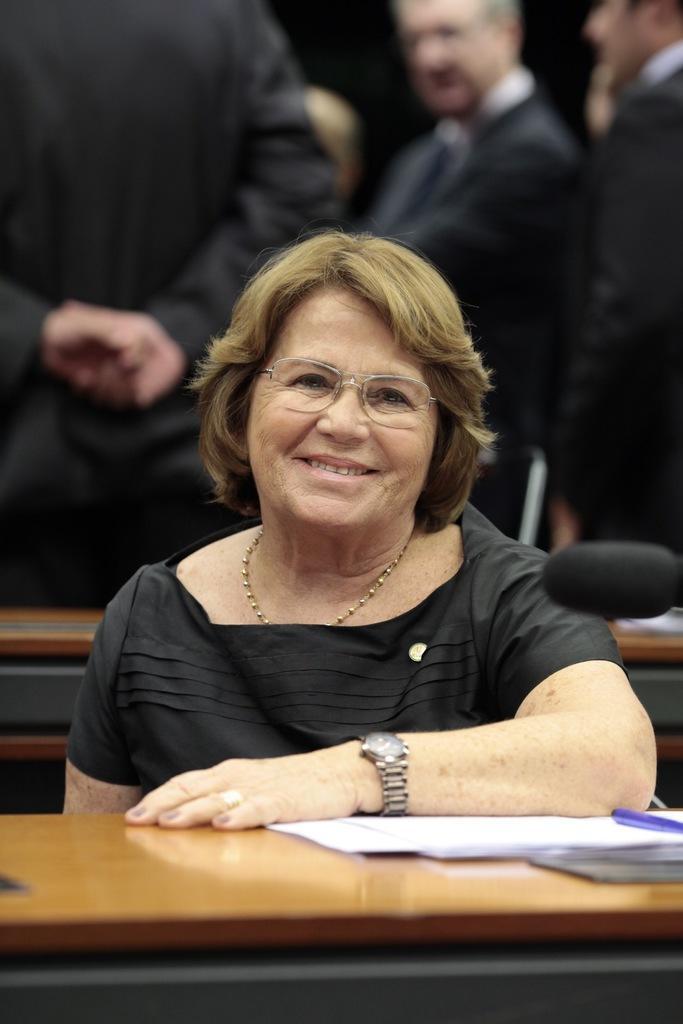Please provide a concise description of this image. In the image we can see a woman wearing clothes, wrist watch, finger ring, neck chain, spectacle and the woman is smiling. In front of her there is a table, on the table there are papers and an object blue in color. Behind her there are many other people standing and they are wearing clothes.  